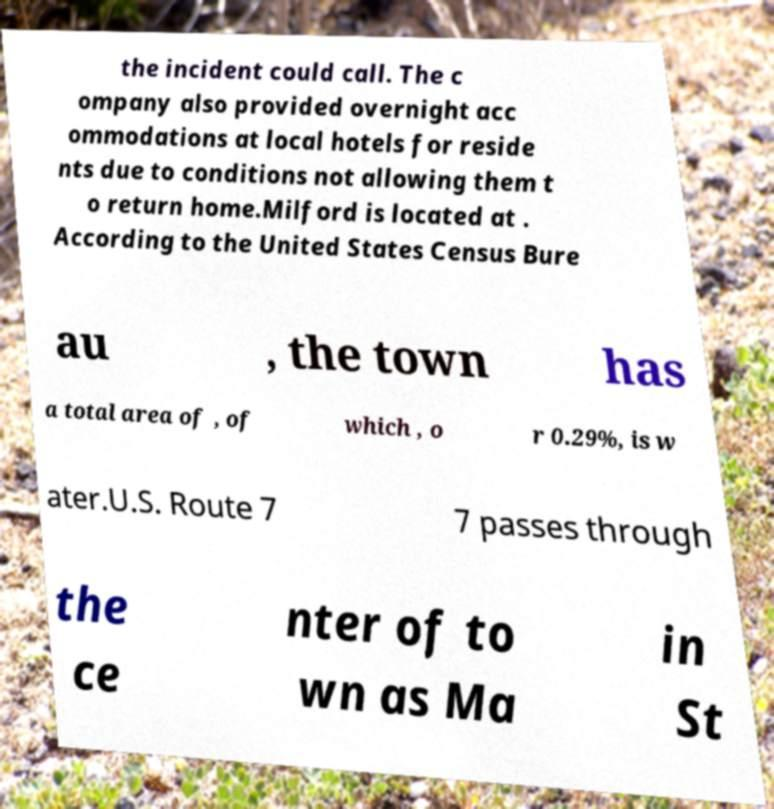Please read and relay the text visible in this image. What does it say? the incident could call. The c ompany also provided overnight acc ommodations at local hotels for reside nts due to conditions not allowing them t o return home.Milford is located at . According to the United States Census Bure au , the town has a total area of , of which , o r 0.29%, is w ater.U.S. Route 7 7 passes through the ce nter of to wn as Ma in St 